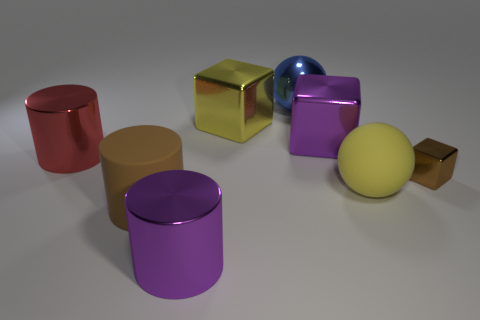Is there any other thing that has the same size as the brown cube?
Your answer should be compact. No. Does the yellow ball have the same size as the brown block?
Offer a very short reply. No. Is the number of small brown metallic blocks that are to the left of the tiny cube the same as the number of red shiny cylinders in front of the big brown rubber object?
Your answer should be very brief. Yes. Does the purple thing that is to the right of the yellow metal object have the same size as the brown object that is on the left side of the blue shiny thing?
Your answer should be very brief. Yes. What material is the large thing that is both left of the big blue shiny ball and on the right side of the big purple cylinder?
Keep it short and to the point. Metal. Is the number of large gray rubber cylinders less than the number of large yellow spheres?
Provide a short and direct response. Yes. What is the size of the thing that is behind the yellow thing behind the tiny block?
Your answer should be compact. Large. There is a brown object that is right of the matte object to the left of the cylinder that is in front of the large brown rubber object; what shape is it?
Offer a terse response. Cube. What is the color of the tiny cube that is made of the same material as the blue object?
Give a very brief answer. Brown. There is a metallic thing that is right of the ball in front of the big cylinder behind the brown shiny block; what is its color?
Give a very brief answer. Brown. 